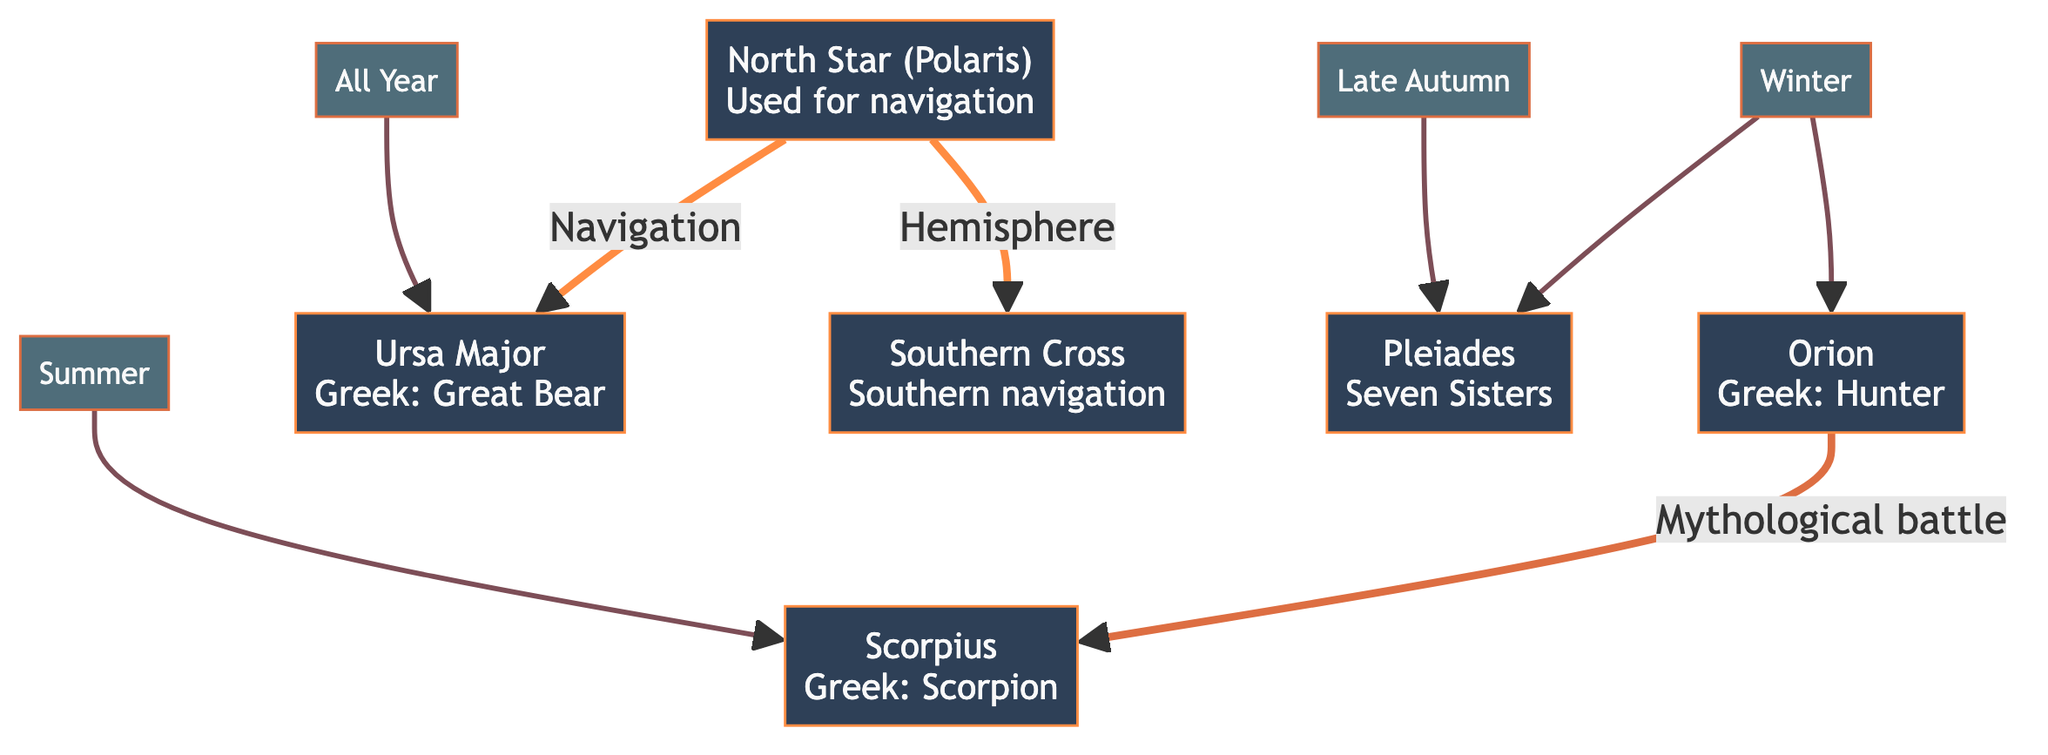What constellations are associated with winter? The diagram clearly shows that both Orion and Pleiades are linked with the Winter node. The direct connection indicates that these two constellations are typically viewed or recognized during the winter season.
Answer: Orion, Pleiades How many seasonal constellations are listed in the diagram? By counting the distinct season nodes connected to constellations in the diagram, we find Winter, Summer, All Year, and Late Autumn, which totals four seasonal connections to specific constellations.
Answer: 4 Which constellation represents a mythological battle? The diagram indicates that Orion is connected to Scorpius with a label stating "Mythological battle." This relationship highlights that these two constellations are tied together through mythological context.
Answer: Orion Which constellation can be seen all year round? The diagram connects Ursa Major to the All Year node, indicating that this constellation is visible throughout the year without seasonal limitations.
Answer: Ursa Major What is the significance of the North Star in navigation? Observing the diagram, the North Star (Polaris) shows connections to Ursa Major and Southern Cross with a label relating to navigation. This indicates its importance for sailors and travelers for orientation.
Answer: Navigation How many constellations are associated with summer? Only one constellation, Scorpius, is connected directly to the Summer node in the diagram, indicating that it is associated specifically with this season.
Answer: 1 Which seasonal constellation is associated with both winter and autumn? The diagram shows that Pleiades is linked with both the Winter and Late Autumn nodes. This connection suggests its visibility in both seasons.
Answer: Pleiades What does Ursa Major signify in the context of hemispheres? The diagram states that Ursa Major is connected to the North Star in terms of hemisphere navigation, indicating its importance in identifying locations based on celestial navigation in the Northern Hemisphere.
Answer: Hemisphere 